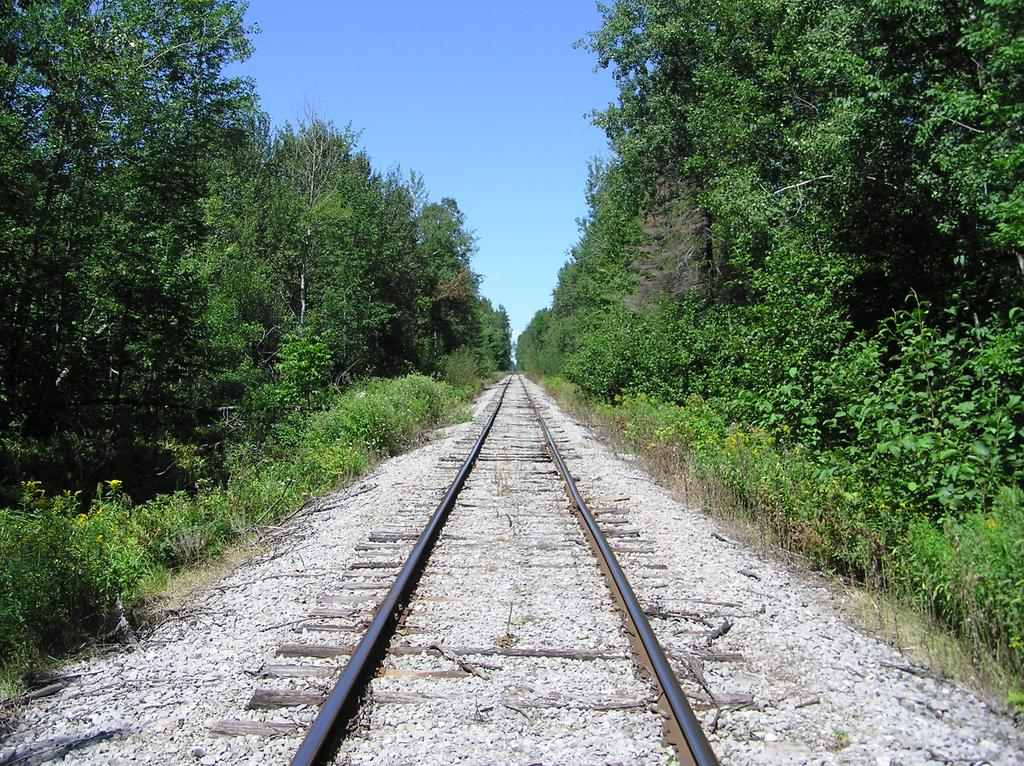What is the main feature of the image? There is a railway track in the image. What can be seen beside the railway track? There are trees and plants beside the railway track. What type of magic is being performed on the paper in the image? There is no paper or magic present in the image; it only features a railway track and surrounding trees and plants. 